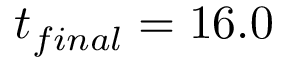<formula> <loc_0><loc_0><loc_500><loc_500>t _ { f i n a l } = 1 6 . 0</formula> 